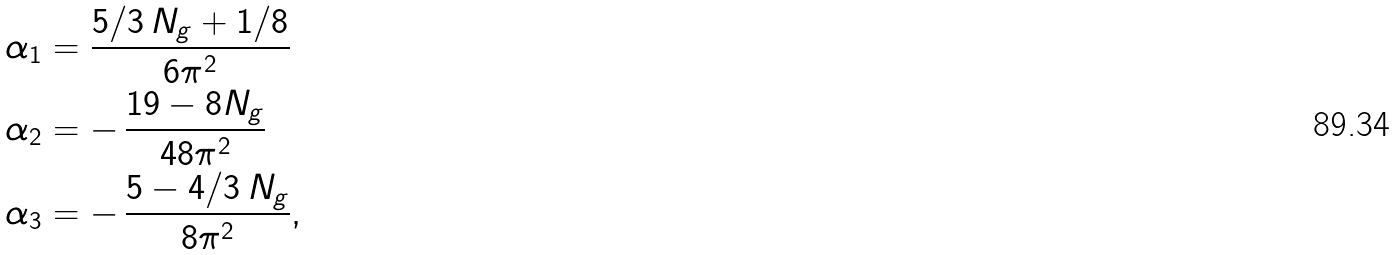Convert formula to latex. <formula><loc_0><loc_0><loc_500><loc_500>\alpha _ { 1 } & = \frac { 5 / 3 \, N _ { g } + 1 / 8 } { 6 \pi ^ { 2 } } \\ \alpha _ { 2 } & = - \, \frac { 1 9 - 8 N _ { g } } { 4 8 \pi ^ { 2 } } \\ \alpha _ { 3 } & = - \, \frac { 5 - 4 / 3 \, N _ { g } } { 8 \pi ^ { 2 } } ,</formula> 